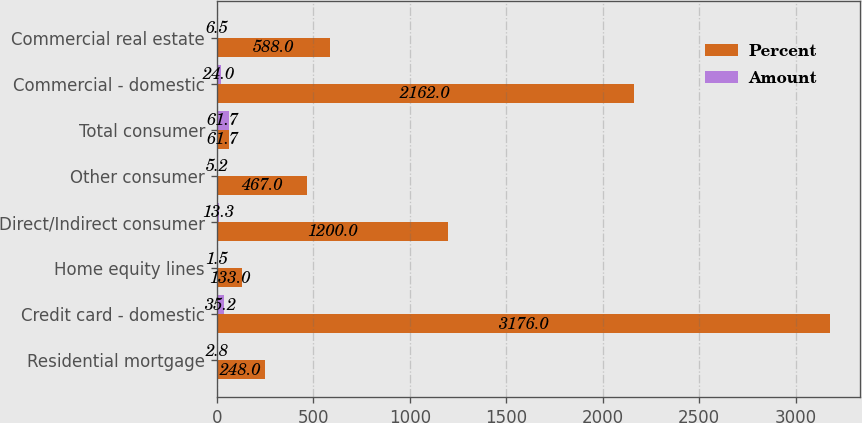<chart> <loc_0><loc_0><loc_500><loc_500><stacked_bar_chart><ecel><fcel>Residential mortgage<fcel>Credit card - domestic<fcel>Home equity lines<fcel>Direct/Indirect consumer<fcel>Other consumer<fcel>Total consumer<fcel>Commercial - domestic<fcel>Commercial real estate<nl><fcel>Percent<fcel>248<fcel>3176<fcel>133<fcel>1200<fcel>467<fcel>61.7<fcel>2162<fcel>588<nl><fcel>Amount<fcel>2.8<fcel>35.2<fcel>1.5<fcel>13.3<fcel>5.2<fcel>61.7<fcel>24<fcel>6.5<nl></chart> 